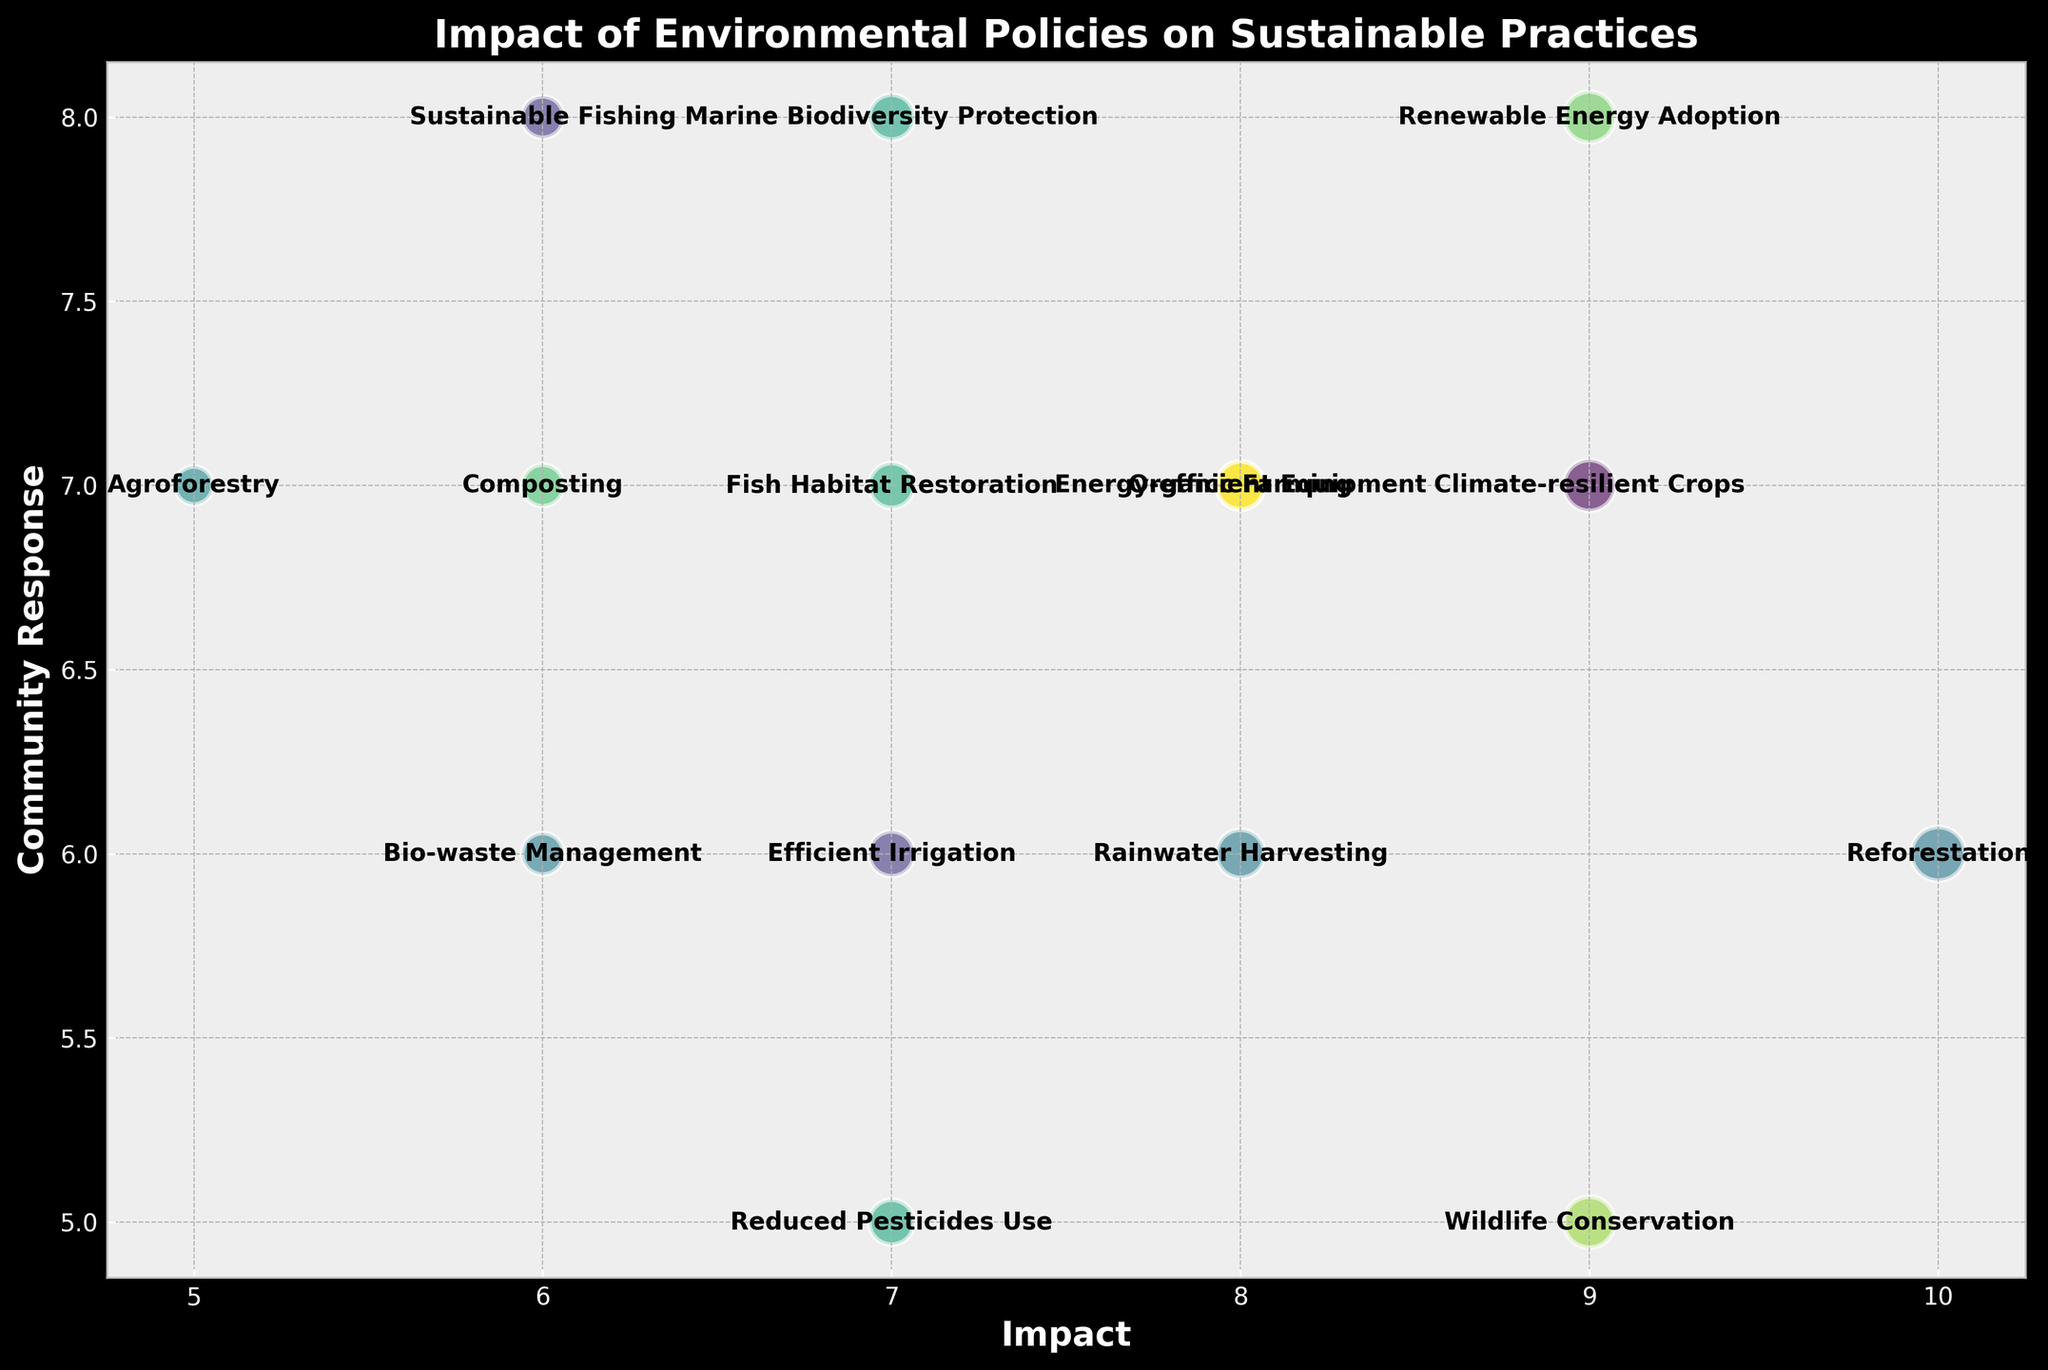Which sustainable practice has the highest impact? The highest impact can be seen on the x-axis. The practice with the bubble placed at the maximum x value represents the highest impact.
Answer: Reforestation Which sustainable practice has the lowest community response? The lowest community response can be seen on the y-axis. The practice with the bubble placed at the minimum y value represents the lowest response.
Answer: Wildlife Conservation Which practice has both an impact and community response score of 7? Look for the bubble centered at x=7 and y=7. The label inside this bubble represents the practice with both scores as 7.
Answer: Fish Habitat Restoration What is the difference between the impact of ‘Renewable Energy Adoption’ and ‘Agroforestry’? Find the x-axis values corresponding to the labels ‘Renewable Energy Adoption’ and ‘Agroforestry’. Subtract the impact score of ‘Agroforestry’ from that of ‘Renewable Energy Adoption’.
Answer: 4 Which practice showed an almost equal response from the community compared to its impact? Check for bubbles where the x and y coordinates are very close or equal. Identify the label in these bubbles.
Answer: Organic Farming Across all practices, which one received the highest community response? Look at the y-axis and identify the bubble with the maximum y value. The label inside this bubble represents the highest community response.
Answer: Sustainable Fishing How many sustainable practices have an impact score of 8 or higher? Count all bubbles placed at or beyond the x value of 8.
Answer: 5 Which sustainable practice has an impact score of 10, and what is its community response? Find the bubble centered at x=10. The label inside this bubble represents the practice, and the corresponding y value indicates the community response.
Answer: Reforestation, 6 Compare the impact and community response for ‘Composting’ and ‘Bio-waste Management’. Which has a higher impact, and which received a higher community response? Identify the x and y values for both 'Composting' and 'Bio-waste Management'. Compare their x values for impact and y values for community response.
Answer: Composting has a higher impact, Bio-waste Management has a higher community response What is the average community response for practices with an impact score of 7? Identify all bubbles centered at x=7. Extract their y values and calculate the average.
Answer: 6 